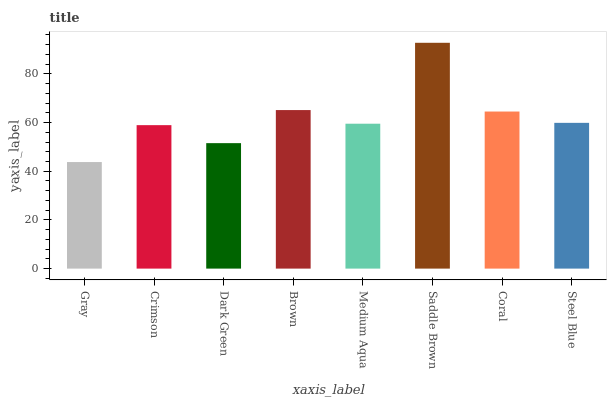Is Crimson the minimum?
Answer yes or no. No. Is Crimson the maximum?
Answer yes or no. No. Is Crimson greater than Gray?
Answer yes or no. Yes. Is Gray less than Crimson?
Answer yes or no. Yes. Is Gray greater than Crimson?
Answer yes or no. No. Is Crimson less than Gray?
Answer yes or no. No. Is Steel Blue the high median?
Answer yes or no. Yes. Is Medium Aqua the low median?
Answer yes or no. Yes. Is Gray the high median?
Answer yes or no. No. Is Brown the low median?
Answer yes or no. No. 